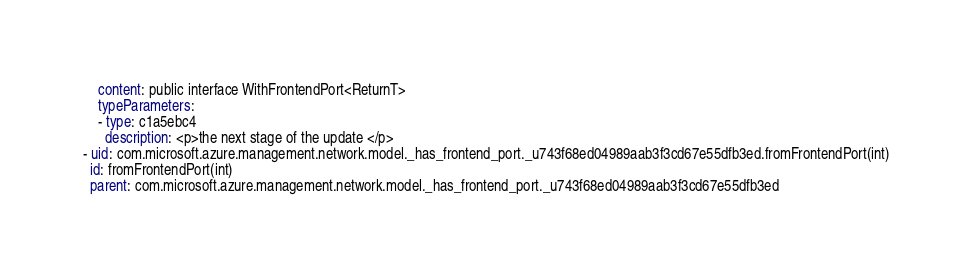Convert code to text. <code><loc_0><loc_0><loc_500><loc_500><_YAML_>    content: public interface WithFrontendPort<ReturnT>
    typeParameters:
    - type: c1a5ebc4
      description: <p>the next stage of the update </p>
- uid: com.microsoft.azure.management.network.model._has_frontend_port._u743f68ed04989aab3f3cd67e55dfb3ed.fromFrontendPort(int)
  id: fromFrontendPort(int)
  parent: com.microsoft.azure.management.network.model._has_frontend_port._u743f68ed04989aab3f3cd67e55dfb3ed</code> 